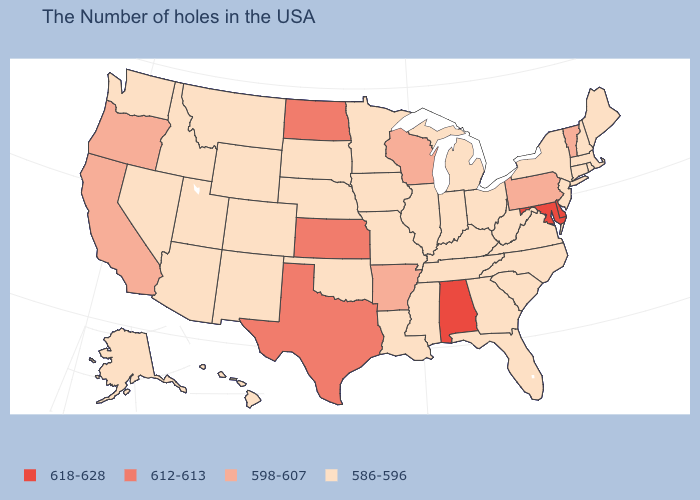What is the lowest value in states that border Vermont?
Concise answer only. 586-596. What is the value of Florida?
Keep it brief. 586-596. What is the value of Oregon?
Be succinct. 598-607. What is the value of Delaware?
Short answer required. 618-628. How many symbols are there in the legend?
Give a very brief answer. 4. What is the highest value in states that border Colorado?
Short answer required. 612-613. What is the highest value in the USA?
Quick response, please. 618-628. Which states have the lowest value in the USA?
Concise answer only. Maine, Massachusetts, Rhode Island, New Hampshire, Connecticut, New York, New Jersey, Virginia, North Carolina, South Carolina, West Virginia, Ohio, Florida, Georgia, Michigan, Kentucky, Indiana, Tennessee, Illinois, Mississippi, Louisiana, Missouri, Minnesota, Iowa, Nebraska, Oklahoma, South Dakota, Wyoming, Colorado, New Mexico, Utah, Montana, Arizona, Idaho, Nevada, Washington, Alaska, Hawaii. Name the states that have a value in the range 618-628?
Keep it brief. Delaware, Maryland, Alabama. Which states have the lowest value in the USA?
Quick response, please. Maine, Massachusetts, Rhode Island, New Hampshire, Connecticut, New York, New Jersey, Virginia, North Carolina, South Carolina, West Virginia, Ohio, Florida, Georgia, Michigan, Kentucky, Indiana, Tennessee, Illinois, Mississippi, Louisiana, Missouri, Minnesota, Iowa, Nebraska, Oklahoma, South Dakota, Wyoming, Colorado, New Mexico, Utah, Montana, Arizona, Idaho, Nevada, Washington, Alaska, Hawaii. Does Oklahoma have the highest value in the South?
Concise answer only. No. What is the value of New York?
Be succinct. 586-596. Name the states that have a value in the range 586-596?
Concise answer only. Maine, Massachusetts, Rhode Island, New Hampshire, Connecticut, New York, New Jersey, Virginia, North Carolina, South Carolina, West Virginia, Ohio, Florida, Georgia, Michigan, Kentucky, Indiana, Tennessee, Illinois, Mississippi, Louisiana, Missouri, Minnesota, Iowa, Nebraska, Oklahoma, South Dakota, Wyoming, Colorado, New Mexico, Utah, Montana, Arizona, Idaho, Nevada, Washington, Alaska, Hawaii. Name the states that have a value in the range 598-607?
Write a very short answer. Vermont, Pennsylvania, Wisconsin, Arkansas, California, Oregon. Is the legend a continuous bar?
Quick response, please. No. 